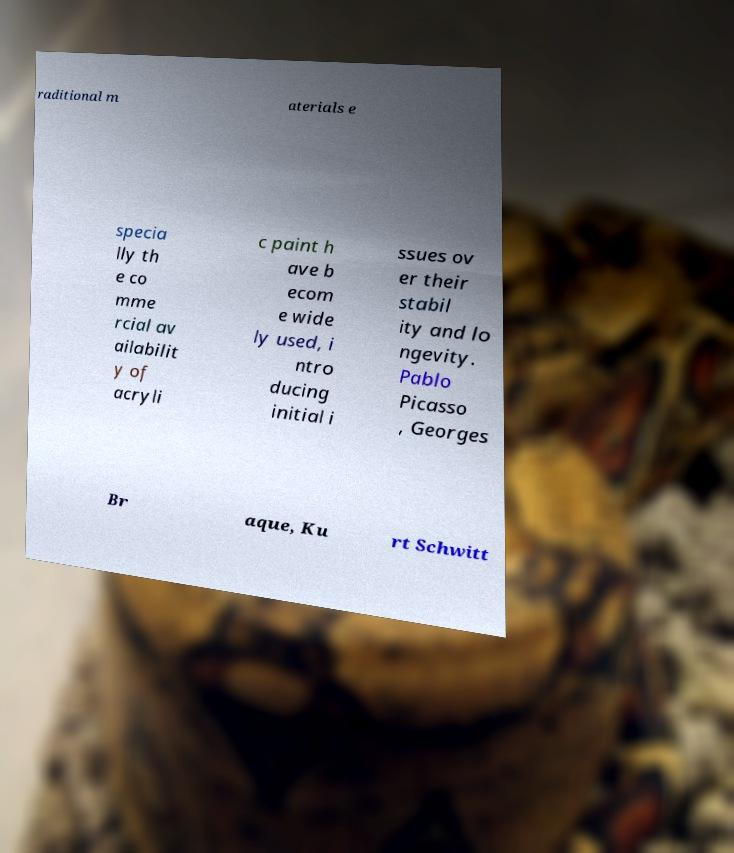Please identify and transcribe the text found in this image. raditional m aterials e specia lly th e co mme rcial av ailabilit y of acryli c paint h ave b ecom e wide ly used, i ntro ducing initial i ssues ov er their stabil ity and lo ngevity. Pablo Picasso , Georges Br aque, Ku rt Schwitt 